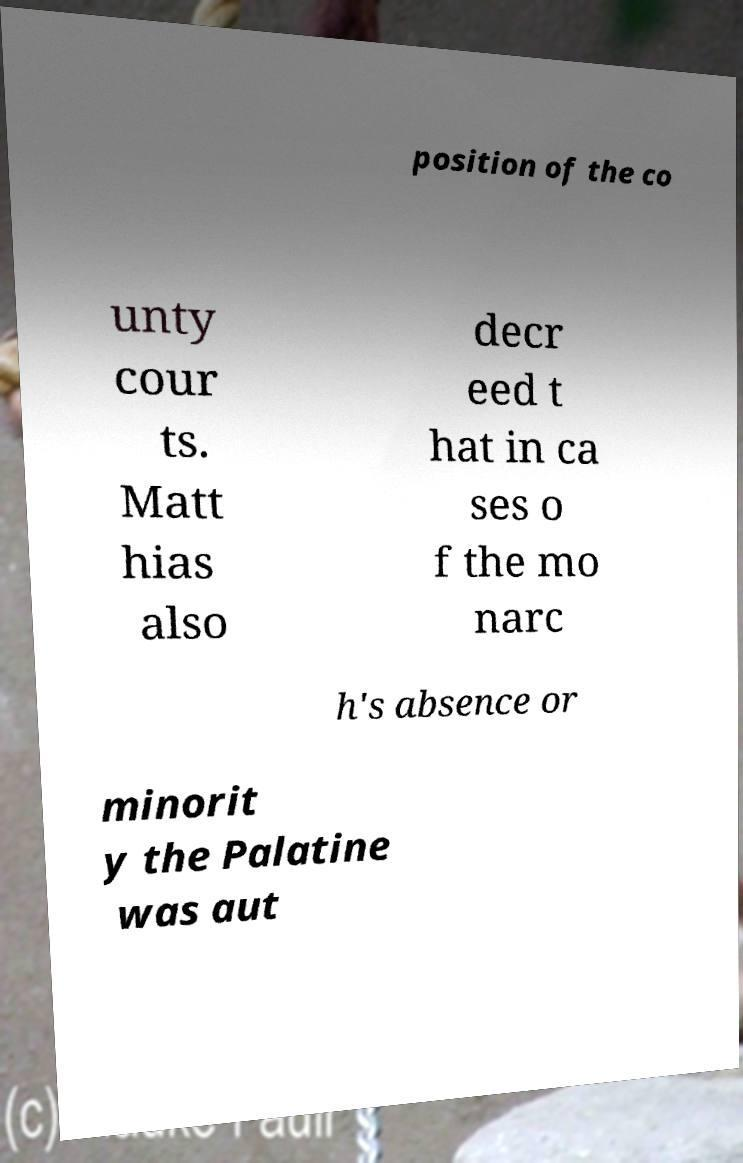Please read and relay the text visible in this image. What does it say? position of the co unty cour ts. Matt hias also decr eed t hat in ca ses o f the mo narc h's absence or minorit y the Palatine was aut 